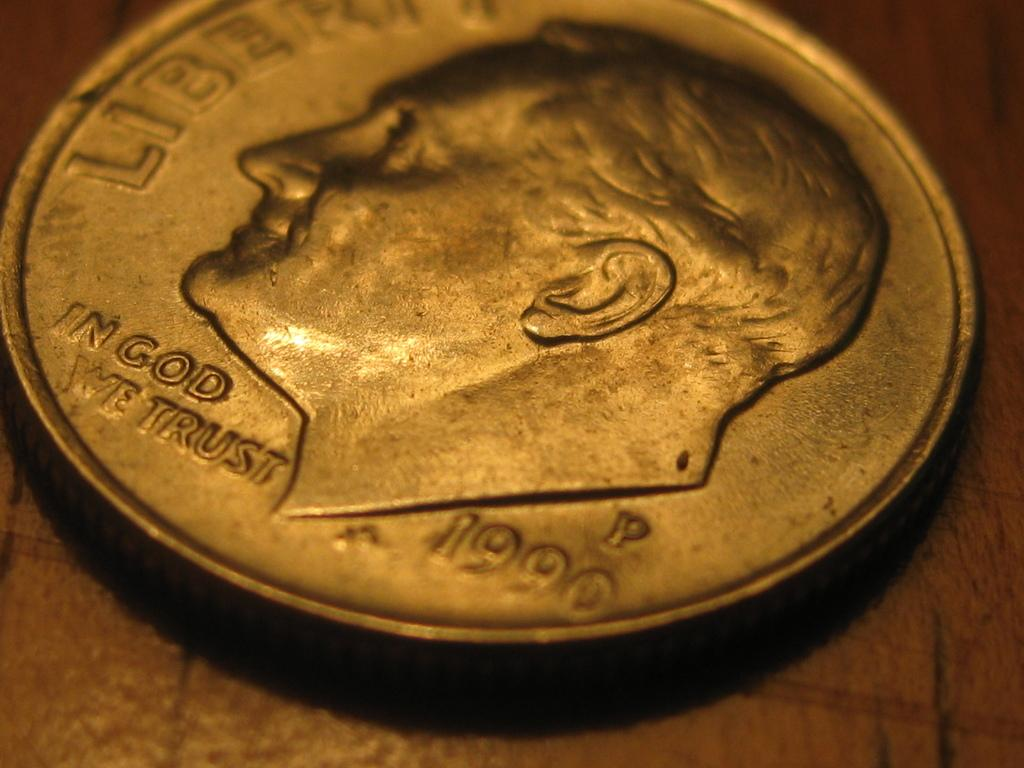<image>
Write a terse but informative summary of the picture. A dime shows that it is from the year 1990. 